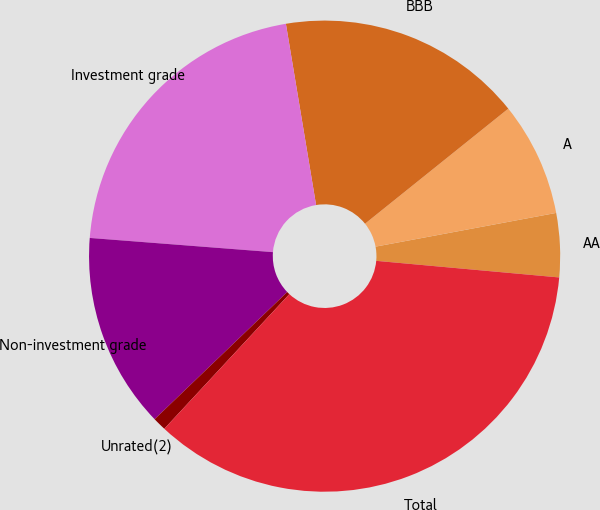Convert chart. <chart><loc_0><loc_0><loc_500><loc_500><pie_chart><fcel>AA<fcel>A<fcel>BBB<fcel>Investment grade<fcel>Non-investment grade<fcel>Unrated(2)<fcel>Total<nl><fcel>4.38%<fcel>7.83%<fcel>16.86%<fcel>21.14%<fcel>13.4%<fcel>0.92%<fcel>35.47%<nl></chart> 